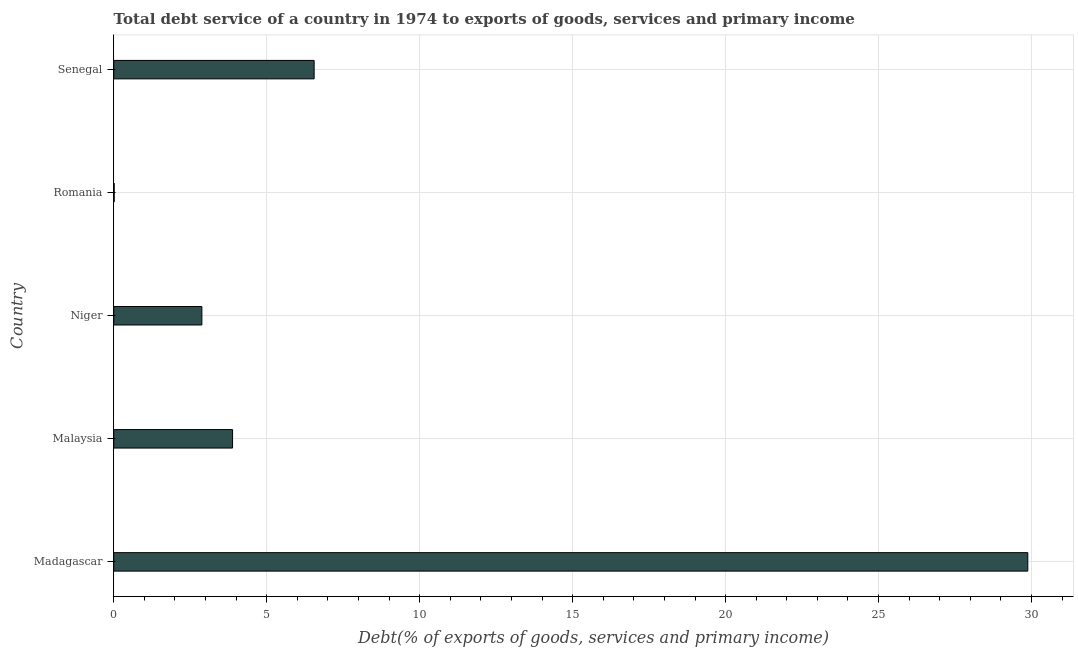What is the title of the graph?
Ensure brevity in your answer.  Total debt service of a country in 1974 to exports of goods, services and primary income. What is the label or title of the X-axis?
Keep it short and to the point. Debt(% of exports of goods, services and primary income). What is the label or title of the Y-axis?
Ensure brevity in your answer.  Country. What is the total debt service in Niger?
Provide a short and direct response. 2.88. Across all countries, what is the maximum total debt service?
Offer a very short reply. 29.88. Across all countries, what is the minimum total debt service?
Offer a terse response. 0.01. In which country was the total debt service maximum?
Offer a very short reply. Madagascar. In which country was the total debt service minimum?
Ensure brevity in your answer.  Romania. What is the sum of the total debt service?
Make the answer very short. 43.21. What is the difference between the total debt service in Niger and Senegal?
Keep it short and to the point. -3.67. What is the average total debt service per country?
Provide a short and direct response. 8.64. What is the median total debt service?
Keep it short and to the point. 3.88. What is the ratio of the total debt service in Madagascar to that in Niger?
Your answer should be very brief. 10.37. Is the total debt service in Romania less than that in Senegal?
Ensure brevity in your answer.  Yes. What is the difference between the highest and the second highest total debt service?
Provide a short and direct response. 23.33. What is the difference between the highest and the lowest total debt service?
Your answer should be compact. 29.86. In how many countries, is the total debt service greater than the average total debt service taken over all countries?
Make the answer very short. 1. Are all the bars in the graph horizontal?
Provide a short and direct response. Yes. How many countries are there in the graph?
Your answer should be very brief. 5. What is the difference between two consecutive major ticks on the X-axis?
Your answer should be compact. 5. Are the values on the major ticks of X-axis written in scientific E-notation?
Your answer should be very brief. No. What is the Debt(% of exports of goods, services and primary income) of Madagascar?
Provide a succinct answer. 29.88. What is the Debt(% of exports of goods, services and primary income) in Malaysia?
Provide a short and direct response. 3.88. What is the Debt(% of exports of goods, services and primary income) in Niger?
Provide a succinct answer. 2.88. What is the Debt(% of exports of goods, services and primary income) of Romania?
Ensure brevity in your answer.  0.01. What is the Debt(% of exports of goods, services and primary income) of Senegal?
Make the answer very short. 6.55. What is the difference between the Debt(% of exports of goods, services and primary income) in Madagascar and Malaysia?
Keep it short and to the point. 25.99. What is the difference between the Debt(% of exports of goods, services and primary income) in Madagascar and Niger?
Your answer should be very brief. 27. What is the difference between the Debt(% of exports of goods, services and primary income) in Madagascar and Romania?
Your answer should be compact. 29.86. What is the difference between the Debt(% of exports of goods, services and primary income) in Madagascar and Senegal?
Your answer should be compact. 23.33. What is the difference between the Debt(% of exports of goods, services and primary income) in Malaysia and Niger?
Your response must be concise. 1. What is the difference between the Debt(% of exports of goods, services and primary income) in Malaysia and Romania?
Your answer should be compact. 3.87. What is the difference between the Debt(% of exports of goods, services and primary income) in Malaysia and Senegal?
Keep it short and to the point. -2.67. What is the difference between the Debt(% of exports of goods, services and primary income) in Niger and Romania?
Give a very brief answer. 2.87. What is the difference between the Debt(% of exports of goods, services and primary income) in Niger and Senegal?
Ensure brevity in your answer.  -3.67. What is the difference between the Debt(% of exports of goods, services and primary income) in Romania and Senegal?
Provide a short and direct response. -6.54. What is the ratio of the Debt(% of exports of goods, services and primary income) in Madagascar to that in Malaysia?
Your answer should be very brief. 7.69. What is the ratio of the Debt(% of exports of goods, services and primary income) in Madagascar to that in Niger?
Provide a succinct answer. 10.37. What is the ratio of the Debt(% of exports of goods, services and primary income) in Madagascar to that in Romania?
Keep it short and to the point. 2054.55. What is the ratio of the Debt(% of exports of goods, services and primary income) in Madagascar to that in Senegal?
Provide a short and direct response. 4.56. What is the ratio of the Debt(% of exports of goods, services and primary income) in Malaysia to that in Niger?
Make the answer very short. 1.35. What is the ratio of the Debt(% of exports of goods, services and primary income) in Malaysia to that in Romania?
Make the answer very short. 267.1. What is the ratio of the Debt(% of exports of goods, services and primary income) in Malaysia to that in Senegal?
Ensure brevity in your answer.  0.59. What is the ratio of the Debt(% of exports of goods, services and primary income) in Niger to that in Romania?
Provide a succinct answer. 198.11. What is the ratio of the Debt(% of exports of goods, services and primary income) in Niger to that in Senegal?
Offer a very short reply. 0.44. What is the ratio of the Debt(% of exports of goods, services and primary income) in Romania to that in Senegal?
Ensure brevity in your answer.  0. 